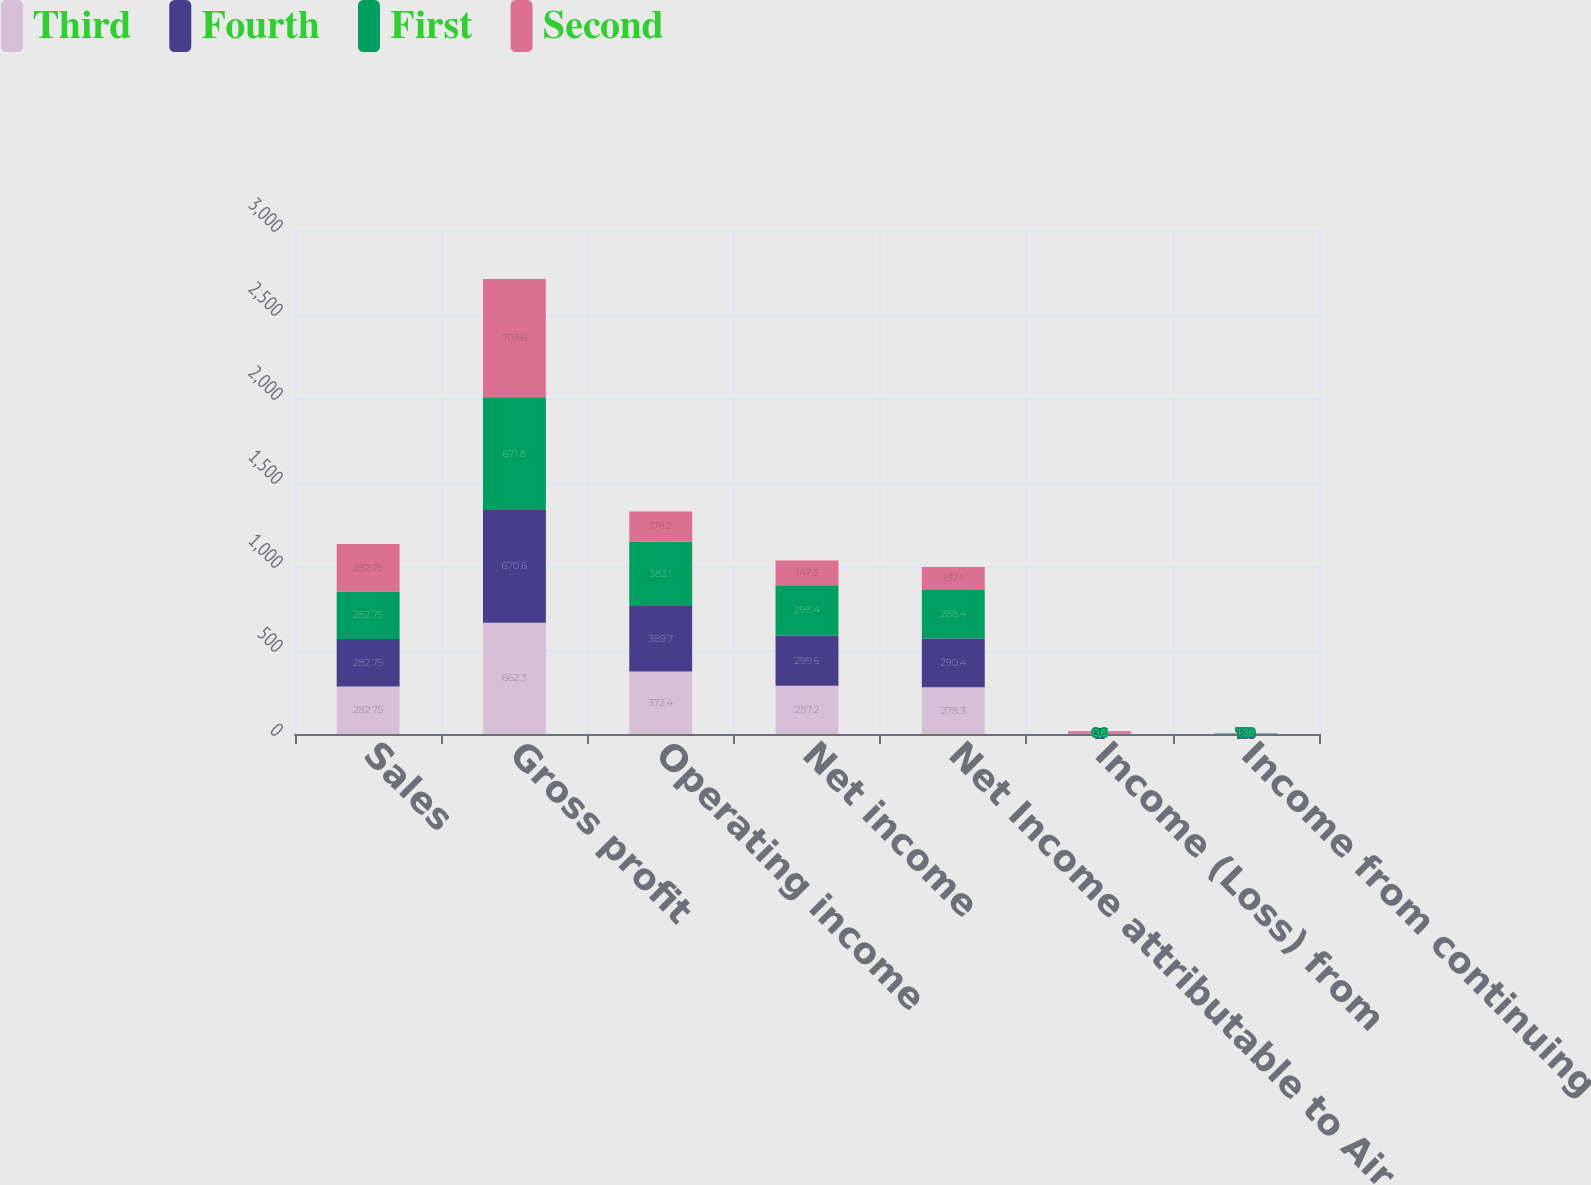Convert chart. <chart><loc_0><loc_0><loc_500><loc_500><stacked_bar_chart><ecel><fcel>Sales<fcel>Gross profit<fcel>Operating income<fcel>Net income<fcel>Net Income attributable to Air<fcel>Income (Loss) from<fcel>Income from continuing<nl><fcel>Third<fcel>282.75<fcel>662.3<fcel>372.4<fcel>287.2<fcel>278.3<fcel>1.4<fcel>1.32<nl><fcel>Fourth<fcel>282.75<fcel>670.6<fcel>389.7<fcel>299.6<fcel>290.4<fcel>1.1<fcel>1.38<nl><fcel>First<fcel>282.75<fcel>671.8<fcel>383.1<fcel>298.4<fcel>288.4<fcel>0.6<fcel>1.38<nl><fcel>Second<fcel>282.75<fcel>703.6<fcel>179.2<fcel>147.3<fcel>137.1<fcel>13.1<fcel>0.71<nl></chart> 